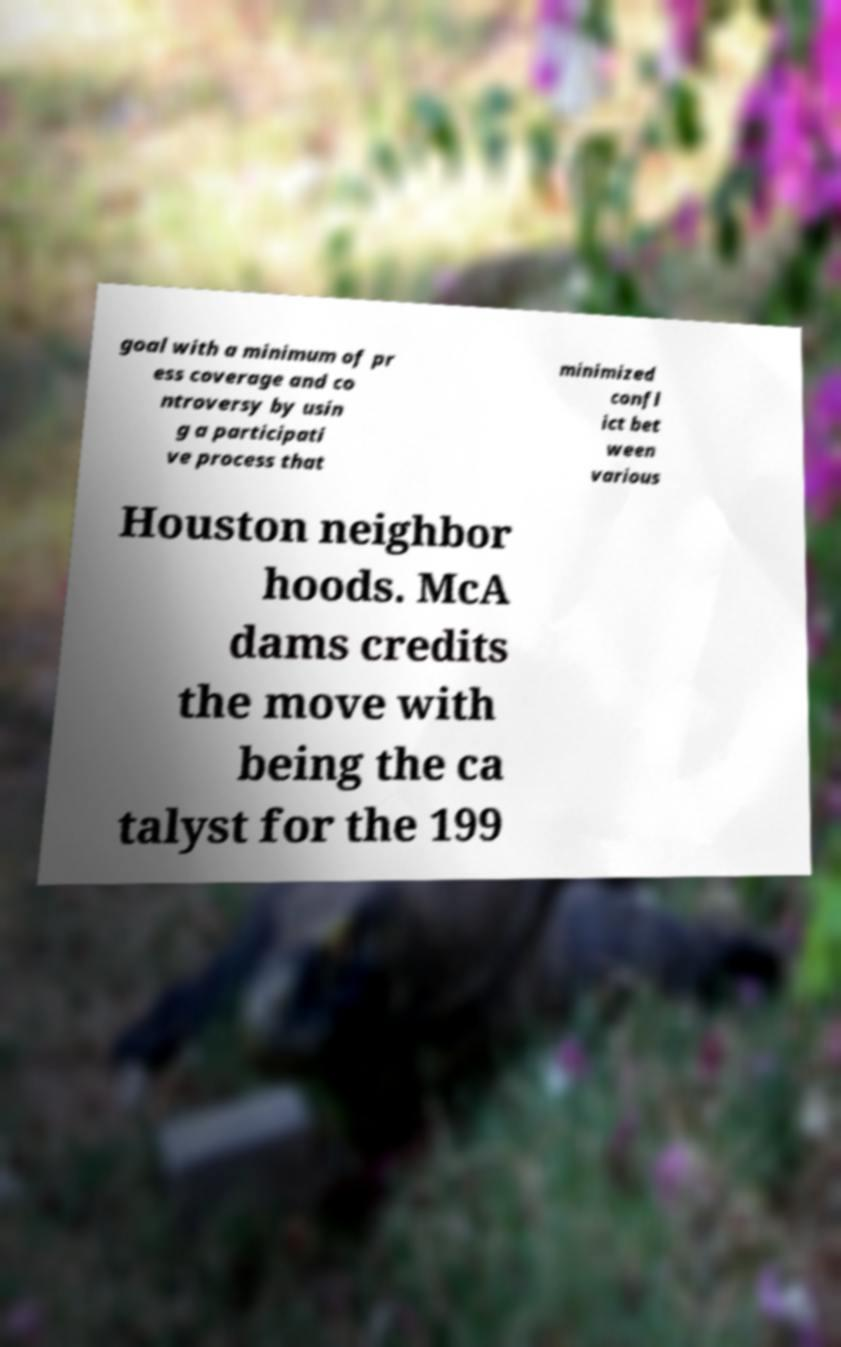Could you extract and type out the text from this image? goal with a minimum of pr ess coverage and co ntroversy by usin g a participati ve process that minimized confl ict bet ween various Houston neighbor hoods. McA dams credits the move with being the ca talyst for the 199 